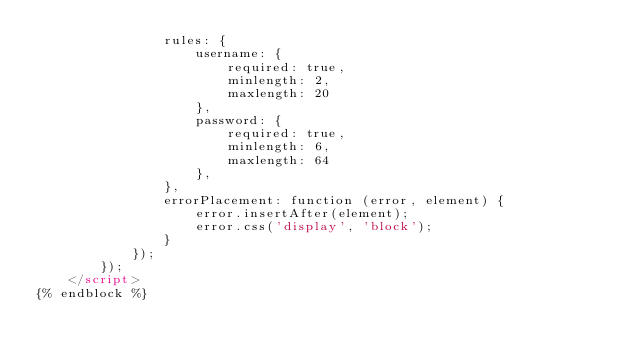<code> <loc_0><loc_0><loc_500><loc_500><_HTML_>                rules: {
                    username: {
                        required: true,
                        minlength: 2,
                        maxlength: 20
                    },
                    password: {
                        required: true,
                        minlength: 6,
                        maxlength: 64
                    },
                },
                errorPlacement: function (error, element) {
                    error.insertAfter(element);
                    error.css('display', 'block');
                }
            });
        });
    </script>
{% endblock %}
</code> 